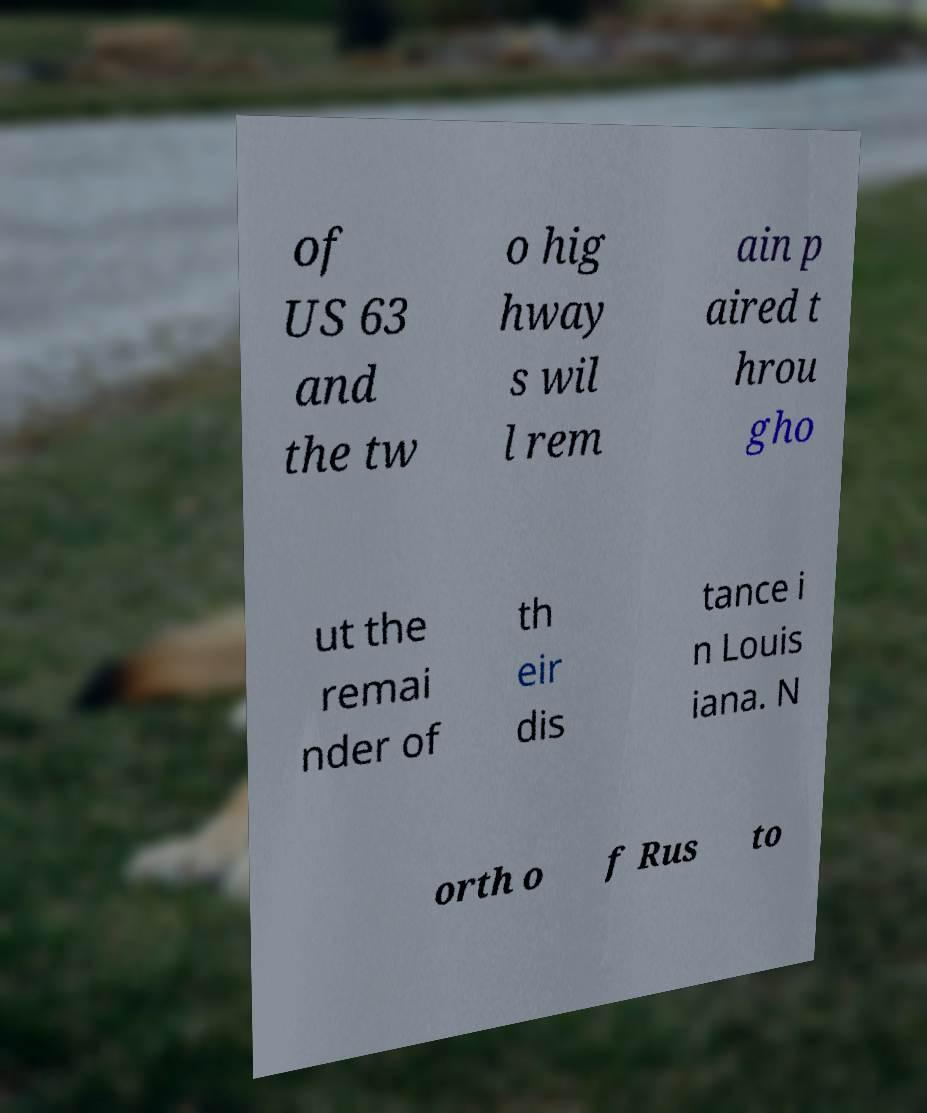Could you assist in decoding the text presented in this image and type it out clearly? of US 63 and the tw o hig hway s wil l rem ain p aired t hrou gho ut the remai nder of th eir dis tance i n Louis iana. N orth o f Rus to 